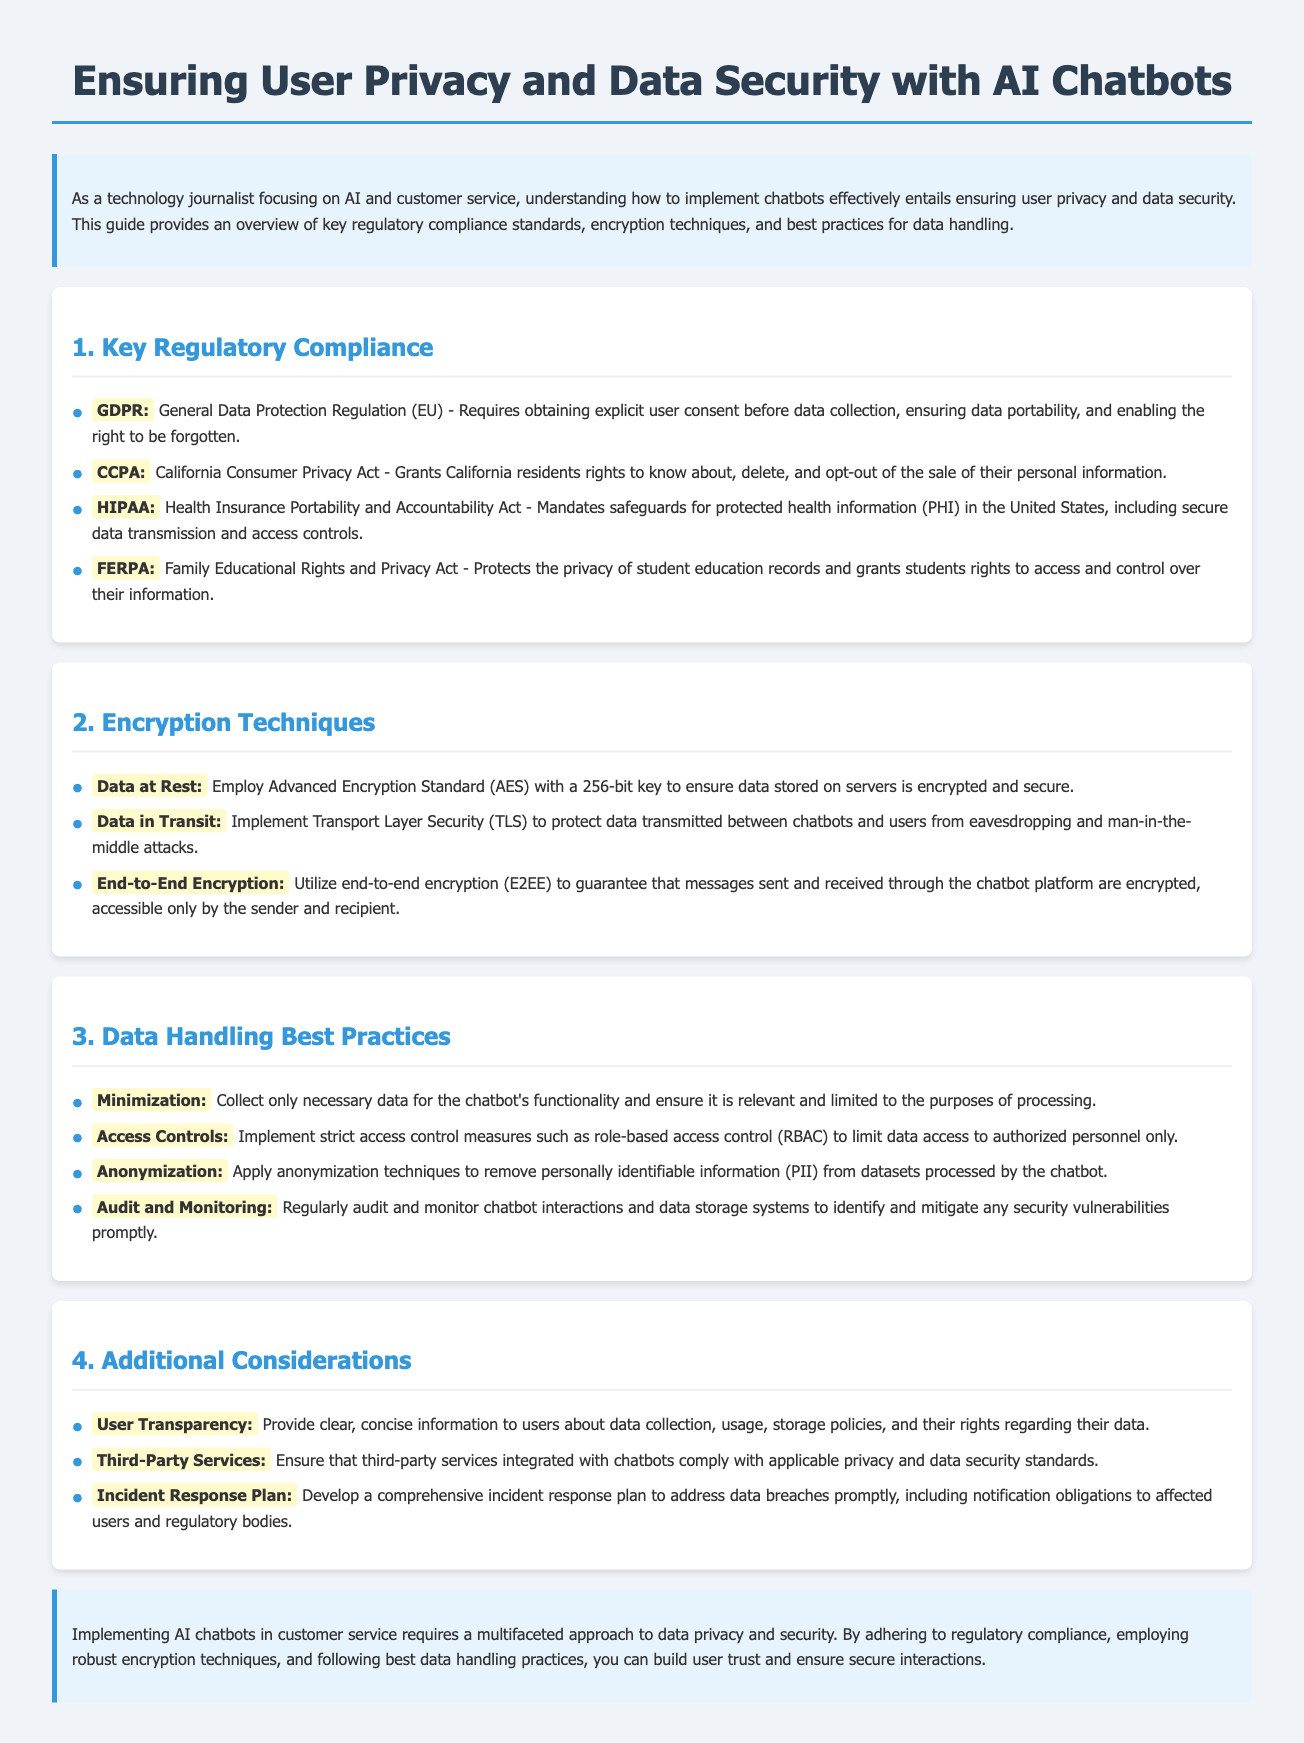What is the primary focus of the document? The document focuses on how to ensure user privacy and data security when implementing AI chatbots in customer service.
Answer: User privacy and data security What does GDPR stand for? GDPR is an abbreviation mentioned in the regulatory compliance section, specifically describing a legal framework in the EU.
Answer: General Data Protection Regulation How should data be encrypted when at rest? The document specifies an encryption technique for data that is stored, focusing on security methods.
Answer: Advanced Encryption Standard What is one example of a data handling best practice? This question requires knowledge of specific practices discussed throughout the document for managing user data effectively.
Answer: Minimization What must be developed to address potential data breaches? The document emphasizes the importance of preparation for data-related incidents, which requires planning.
Answer: Incident Response Plan What encryption method is suggested for data in transit? The document outlines security techniques for protecting data while being transmitted to ensure safety.
Answer: Transport Layer Security Which act protects student education records? This legislative act is mentioned in the context of user privacy regulations relevant to specific demographics.
Answer: FERPA What should users be provided with regarding data policies? User transparency is discussed as an important aspect of building trust regarding data collection.
Answer: Clear, concise information 